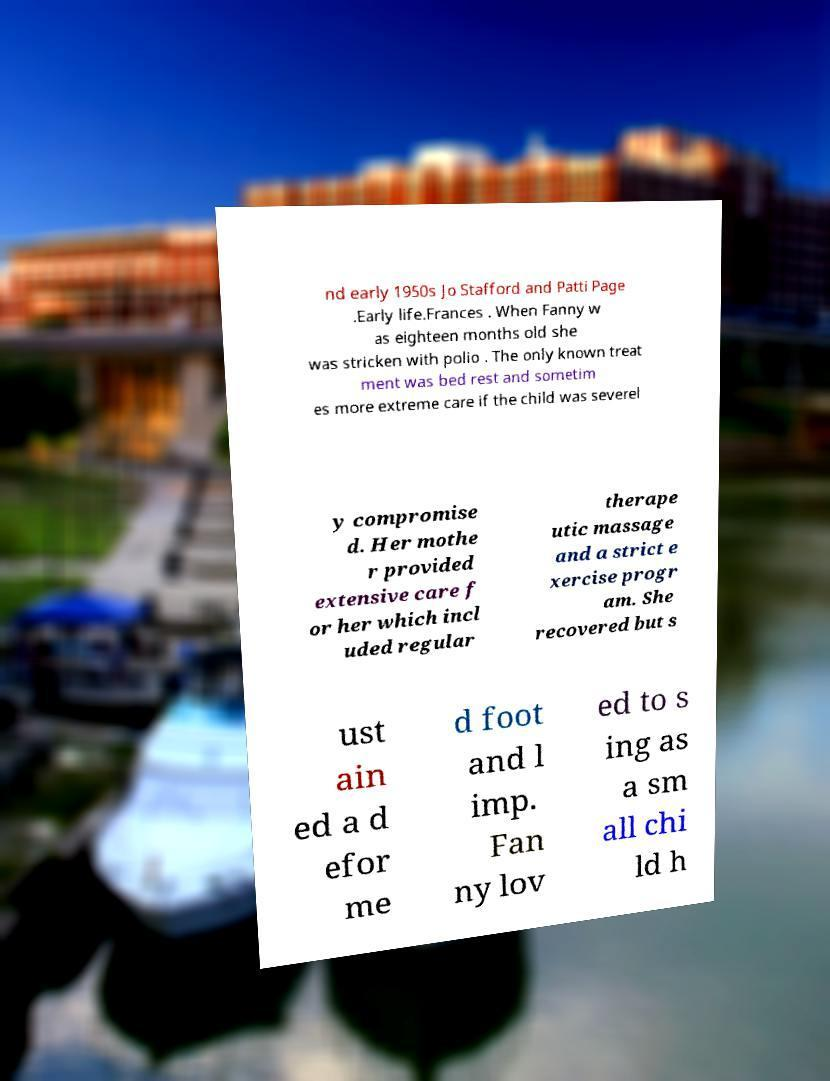I need the written content from this picture converted into text. Can you do that? nd early 1950s Jo Stafford and Patti Page .Early life.Frances . When Fanny w as eighteen months old she was stricken with polio . The only known treat ment was bed rest and sometim es more extreme care if the child was severel y compromise d. Her mothe r provided extensive care f or her which incl uded regular therape utic massage and a strict e xercise progr am. She recovered but s ust ain ed a d efor me d foot and l imp. Fan ny lov ed to s ing as a sm all chi ld h 